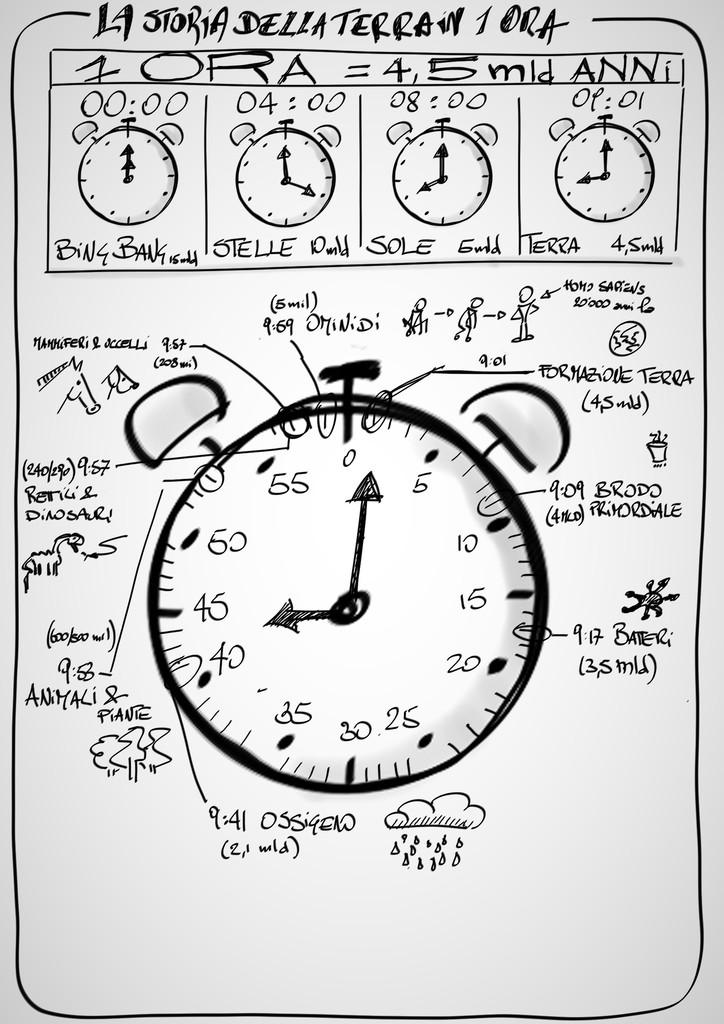What's the formula at the top of the image?
Your answer should be very brief. 1 ora = 4,5 mld anni. 